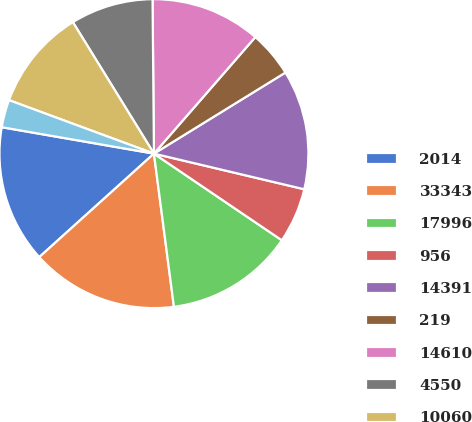<chart> <loc_0><loc_0><loc_500><loc_500><pie_chart><fcel>2014<fcel>33343<fcel>17996<fcel>956<fcel>14391<fcel>219<fcel>14610<fcel>4550<fcel>10060<fcel>173<nl><fcel>14.42%<fcel>15.38%<fcel>13.46%<fcel>5.77%<fcel>12.5%<fcel>4.81%<fcel>11.54%<fcel>8.65%<fcel>10.58%<fcel>2.89%<nl></chart> 